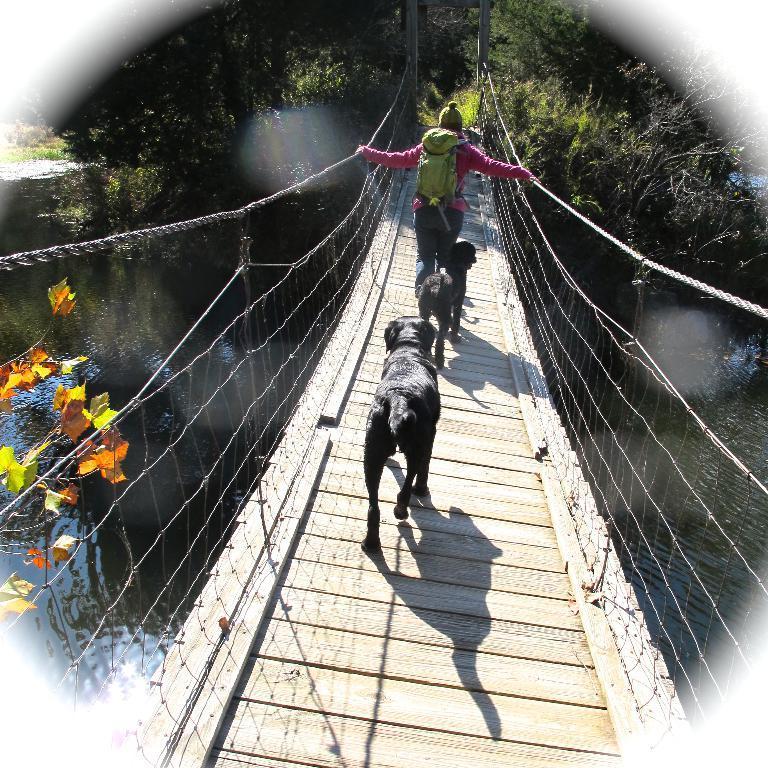In one or two sentences, can you explain what this image depicts? This is an edited image. There is water and there are trees on the left and right corner. It looks like a suspension bridge, there are animals and there is a person in the foreground. And there are trees in the background. 